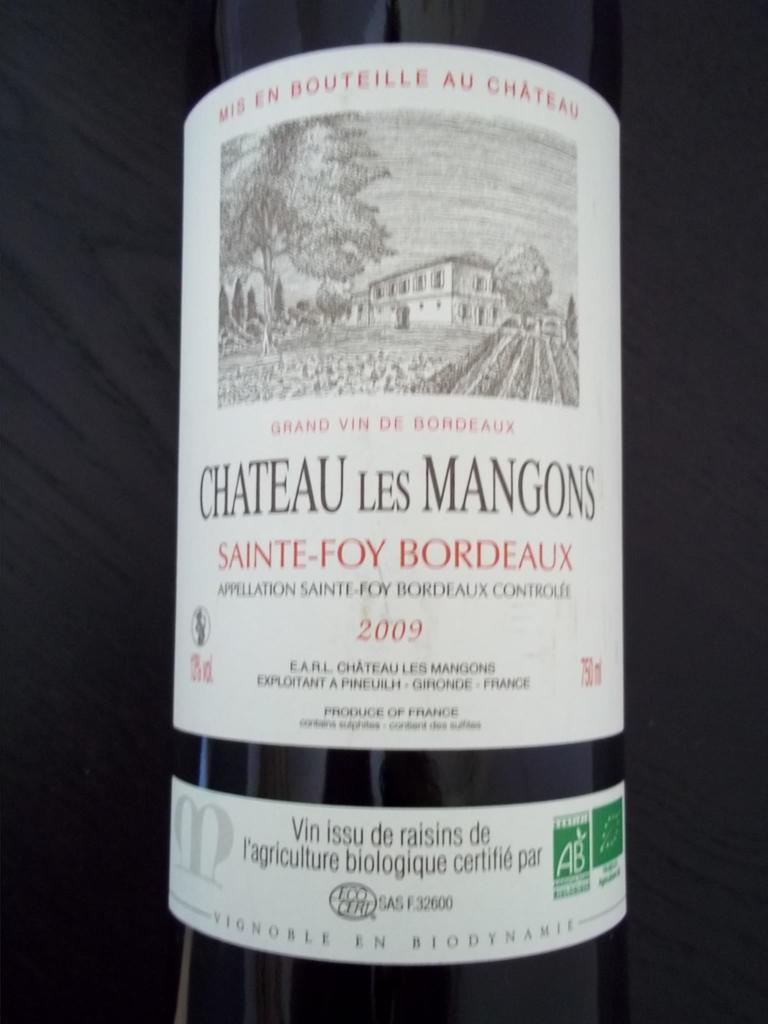Provide a one-sentence caption for the provided image. A bottle from 2009 of Chateau Les Mangons. 